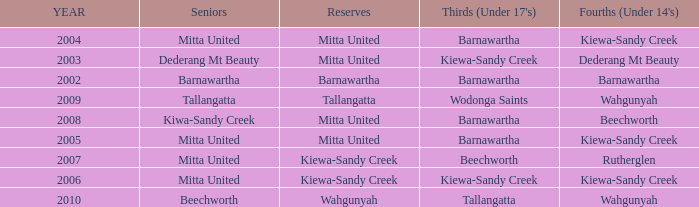Which seniors have a year before 2007, Fourths (Under 14's) of kiewa-sandy creek, and a Reserve of mitta united? Mitta United, Mitta United. 